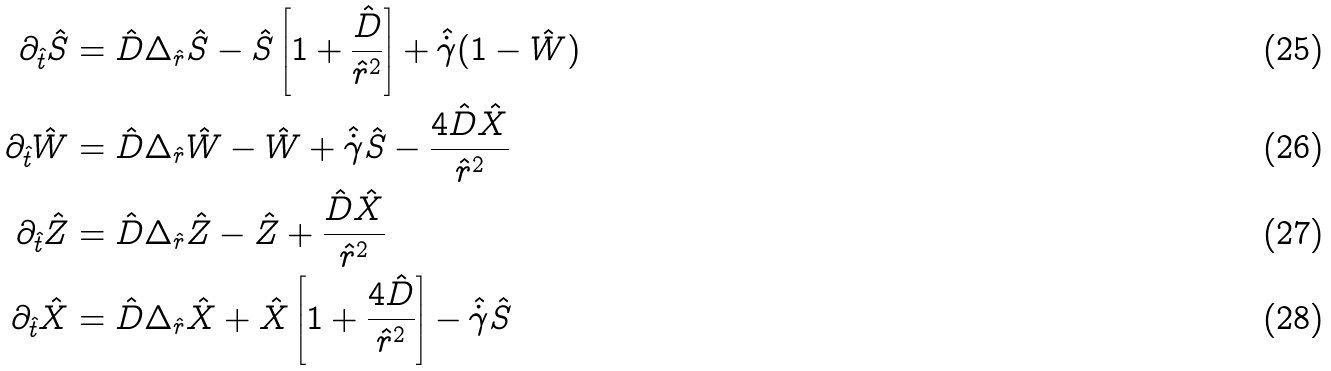Convert formula to latex. <formula><loc_0><loc_0><loc_500><loc_500>\partial _ { \hat { t } } \hat { S } & = \hat { D } \Delta _ { \hat { r } } \hat { S } - \hat { S } \left [ 1 + \frac { \hat { D } } { { \hat { r } } ^ { 2 } } \right ] + \hat { \dot { \gamma } } ( 1 - \hat { W } ) \\ \partial _ { \hat { t } } \hat { W } & = \hat { D } \Delta _ { \hat { r } } \hat { W } - \hat { W } + \hat { \dot { \gamma } } \hat { S } - \frac { 4 \hat { D } \hat { X } } { { \hat { r } } ^ { 2 } } \\ \partial _ { \hat { t } } \hat { Z } & = \hat { D } \Delta _ { \hat { r } } \hat { Z } - \hat { Z } + \frac { \hat { D } \hat { X } } { { \hat { r } } ^ { 2 } } \\ \partial _ { \hat { t } } \hat { X } & = \hat { D } \Delta _ { \hat { r } } \hat { X } + \hat { X } \left [ 1 + \frac { 4 \hat { D } } { { \hat { r } } ^ { 2 } } \right ] - \hat { \dot { \gamma } } \hat { S }</formula> 